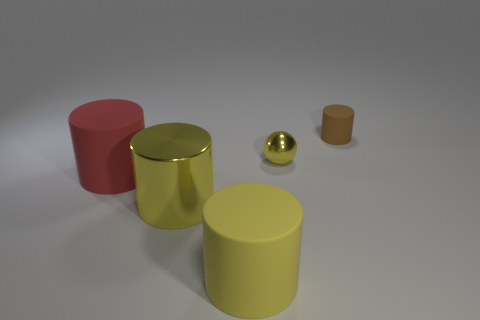Add 1 big yellow balls. How many objects exist? 6 Subtract all red matte cylinders. How many cylinders are left? 3 Subtract all brown cylinders. How many cylinders are left? 3 Subtract all cyan cylinders. Subtract all red spheres. How many cylinders are left? 4 Subtract all purple blocks. How many yellow cylinders are left? 2 Subtract all tiny cylinders. Subtract all yellow matte cylinders. How many objects are left? 3 Add 4 matte objects. How many matte objects are left? 7 Add 2 big gray shiny things. How many big gray shiny things exist? 2 Subtract 0 brown spheres. How many objects are left? 5 Subtract all spheres. How many objects are left? 4 